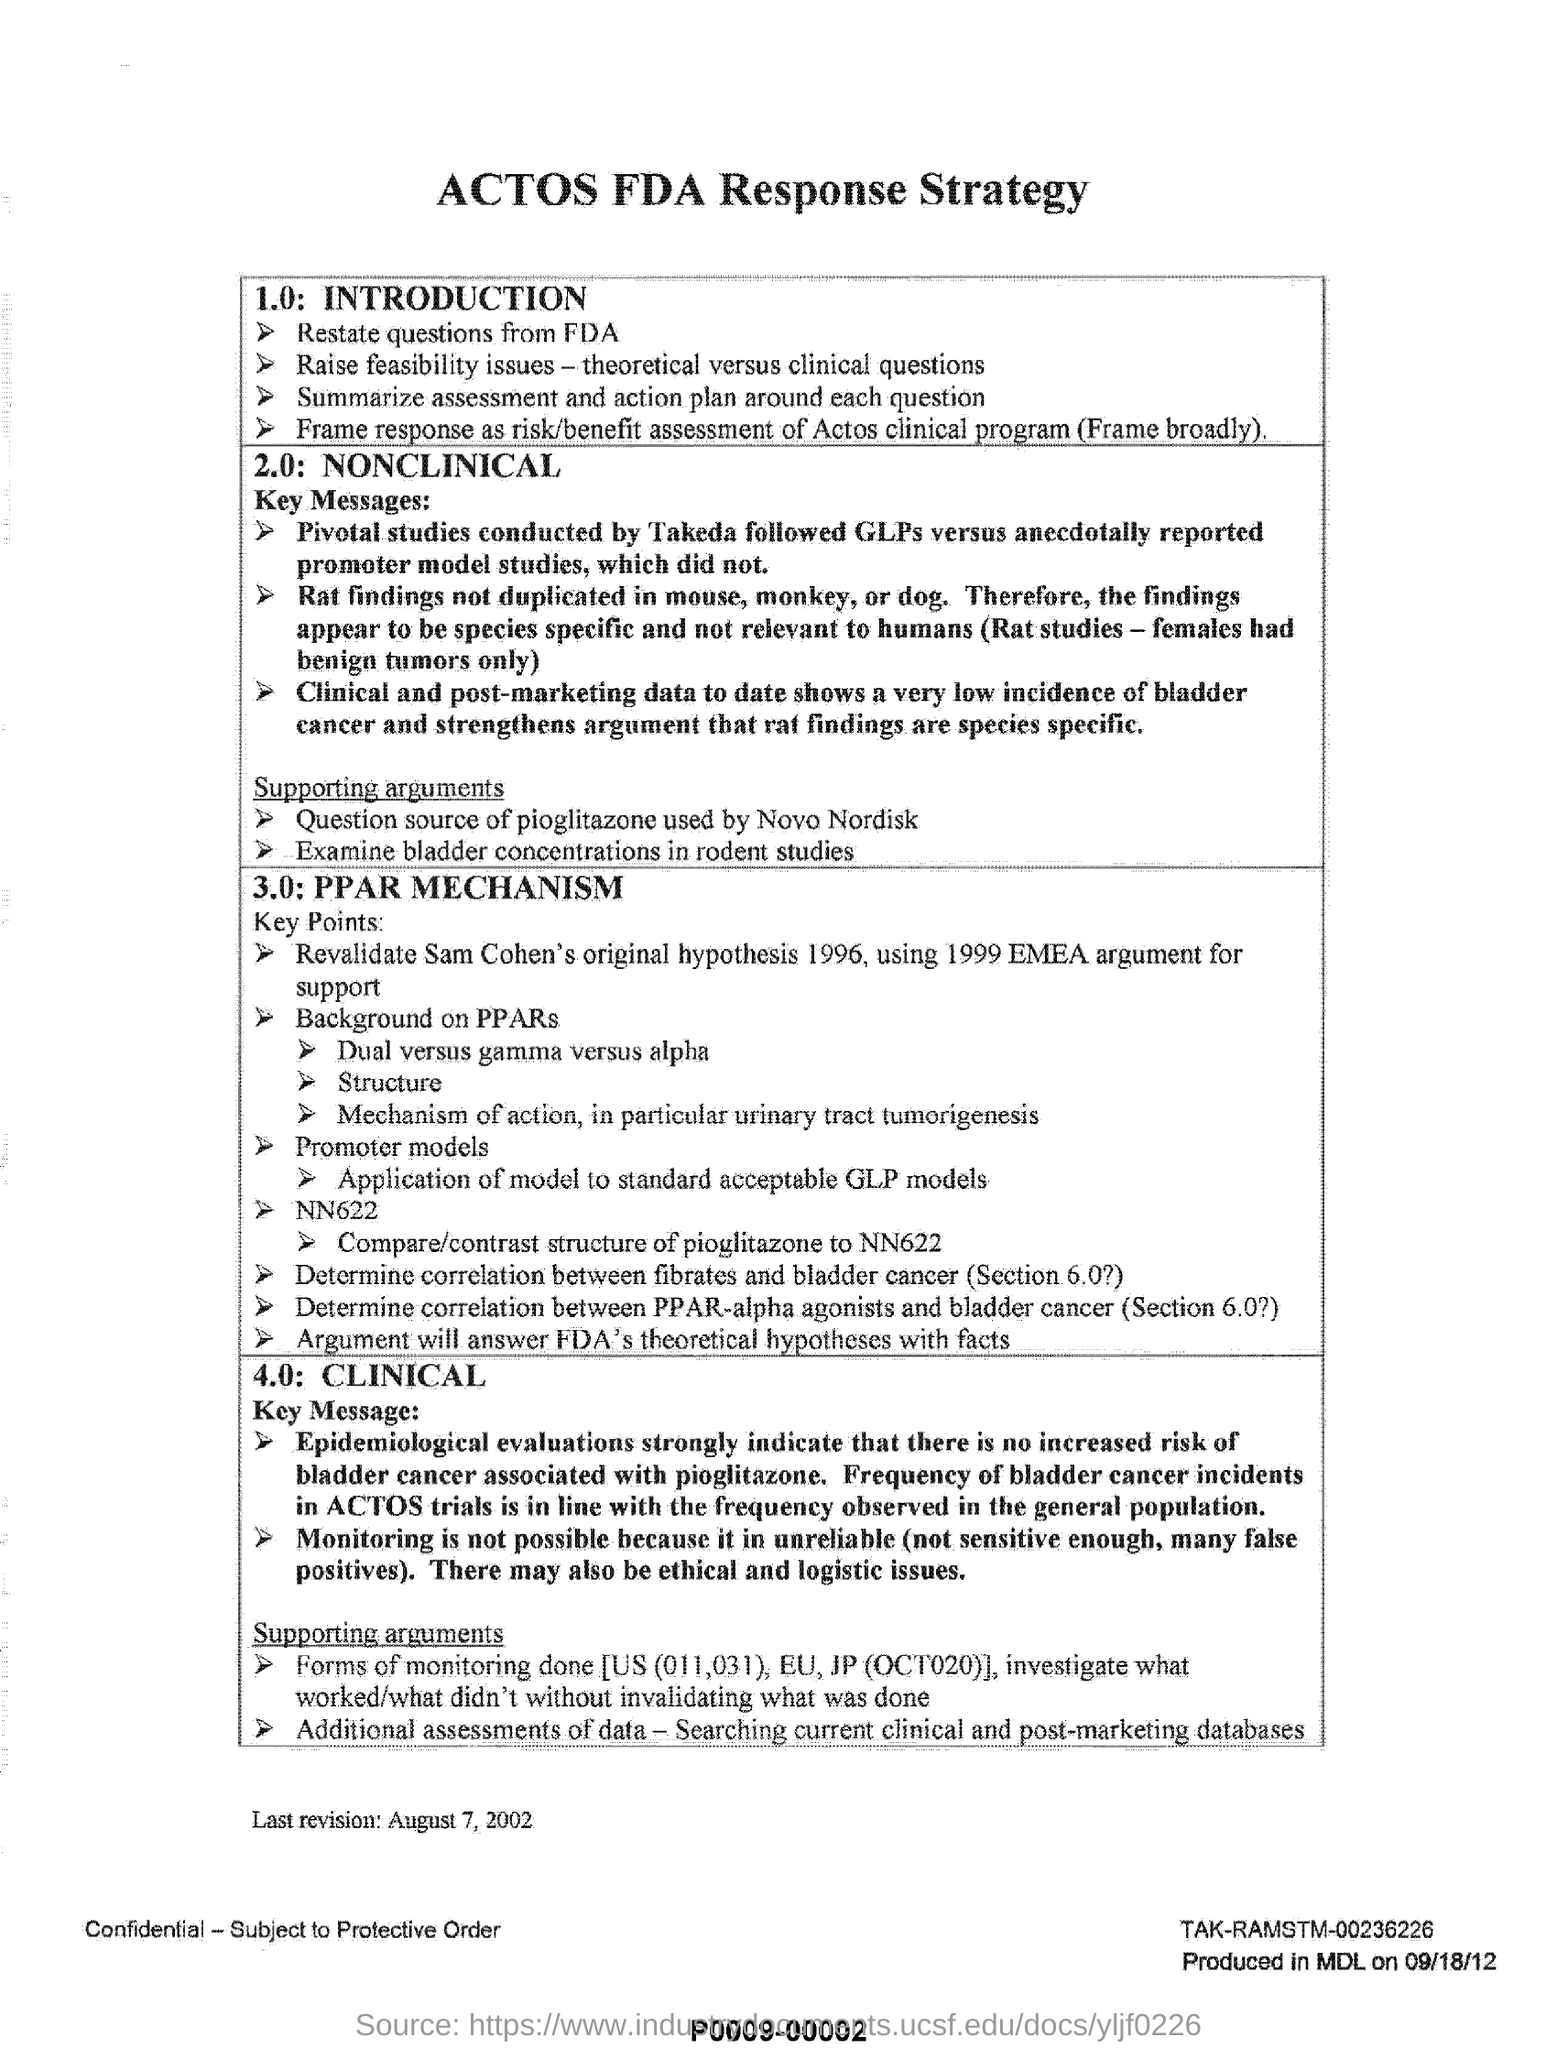Who conducted pivotal studies
Keep it short and to the point. Takeda. What findings are not duplicated in mouse, monkey, or dog?
Your answer should be very brief. Rat Findings. 